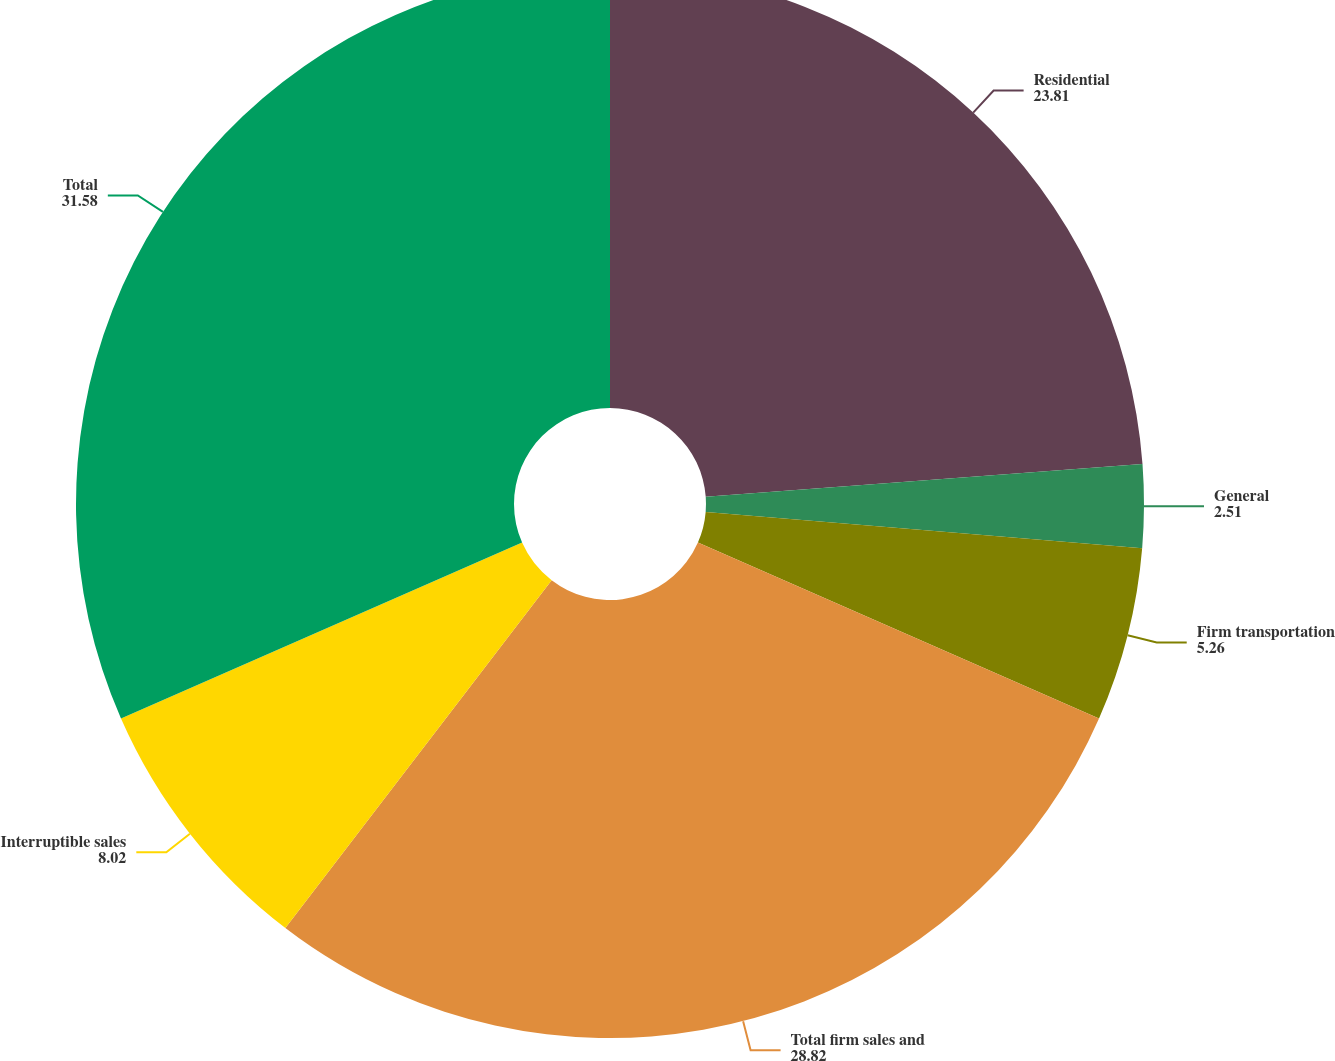Convert chart. <chart><loc_0><loc_0><loc_500><loc_500><pie_chart><fcel>Residential<fcel>General<fcel>Firm transportation<fcel>Total firm sales and<fcel>Interruptible sales<fcel>Total<nl><fcel>23.81%<fcel>2.51%<fcel>5.26%<fcel>28.82%<fcel>8.02%<fcel>31.58%<nl></chart> 